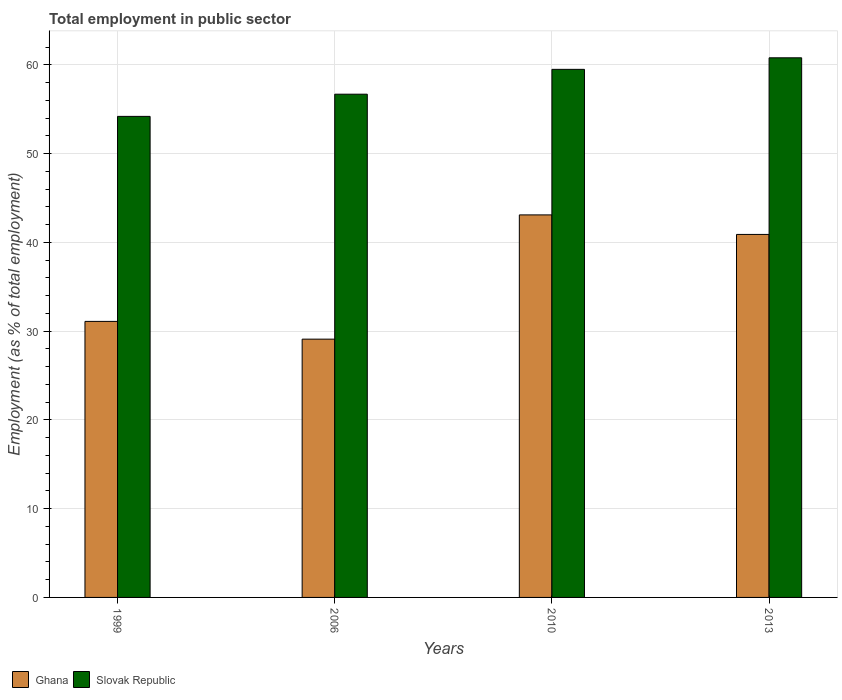How many different coloured bars are there?
Ensure brevity in your answer.  2. Are the number of bars per tick equal to the number of legend labels?
Your answer should be compact. Yes. How many bars are there on the 1st tick from the right?
Ensure brevity in your answer.  2. What is the label of the 4th group of bars from the left?
Keep it short and to the point. 2013. What is the employment in public sector in Ghana in 1999?
Make the answer very short. 31.1. Across all years, what is the maximum employment in public sector in Slovak Republic?
Provide a short and direct response. 60.8. Across all years, what is the minimum employment in public sector in Slovak Republic?
Your response must be concise. 54.2. What is the total employment in public sector in Slovak Republic in the graph?
Provide a short and direct response. 231.2. What is the difference between the employment in public sector in Ghana in 1999 and that in 2006?
Your answer should be very brief. 2. What is the difference between the employment in public sector in Slovak Republic in 2010 and the employment in public sector in Ghana in 2013?
Make the answer very short. 18.6. What is the average employment in public sector in Ghana per year?
Ensure brevity in your answer.  36.05. In the year 2013, what is the difference between the employment in public sector in Slovak Republic and employment in public sector in Ghana?
Your answer should be compact. 19.9. In how many years, is the employment in public sector in Slovak Republic greater than 22 %?
Your response must be concise. 4. What is the ratio of the employment in public sector in Ghana in 2006 to that in 2013?
Provide a succinct answer. 0.71. Is the employment in public sector in Ghana in 2006 less than that in 2010?
Your answer should be compact. Yes. What is the difference between the highest and the second highest employment in public sector in Ghana?
Provide a succinct answer. 2.2. What is the difference between the highest and the lowest employment in public sector in Slovak Republic?
Make the answer very short. 6.6. In how many years, is the employment in public sector in Ghana greater than the average employment in public sector in Ghana taken over all years?
Offer a terse response. 2. Is the sum of the employment in public sector in Slovak Republic in 2006 and 2010 greater than the maximum employment in public sector in Ghana across all years?
Make the answer very short. Yes. What does the 1st bar from the right in 2010 represents?
Your answer should be compact. Slovak Republic. How many bars are there?
Your response must be concise. 8. Are all the bars in the graph horizontal?
Your response must be concise. No. What is the difference between two consecutive major ticks on the Y-axis?
Make the answer very short. 10. Does the graph contain any zero values?
Ensure brevity in your answer.  No. Does the graph contain grids?
Your answer should be compact. Yes. Where does the legend appear in the graph?
Provide a succinct answer. Bottom left. How many legend labels are there?
Provide a succinct answer. 2. What is the title of the graph?
Provide a succinct answer. Total employment in public sector. What is the label or title of the Y-axis?
Offer a terse response. Employment (as % of total employment). What is the Employment (as % of total employment) of Ghana in 1999?
Your answer should be very brief. 31.1. What is the Employment (as % of total employment) of Slovak Republic in 1999?
Your response must be concise. 54.2. What is the Employment (as % of total employment) of Ghana in 2006?
Ensure brevity in your answer.  29.1. What is the Employment (as % of total employment) in Slovak Republic in 2006?
Give a very brief answer. 56.7. What is the Employment (as % of total employment) in Ghana in 2010?
Your response must be concise. 43.1. What is the Employment (as % of total employment) of Slovak Republic in 2010?
Your response must be concise. 59.5. What is the Employment (as % of total employment) of Ghana in 2013?
Give a very brief answer. 40.9. What is the Employment (as % of total employment) in Slovak Republic in 2013?
Ensure brevity in your answer.  60.8. Across all years, what is the maximum Employment (as % of total employment) in Ghana?
Your answer should be compact. 43.1. Across all years, what is the maximum Employment (as % of total employment) in Slovak Republic?
Give a very brief answer. 60.8. Across all years, what is the minimum Employment (as % of total employment) in Ghana?
Keep it short and to the point. 29.1. Across all years, what is the minimum Employment (as % of total employment) in Slovak Republic?
Make the answer very short. 54.2. What is the total Employment (as % of total employment) of Ghana in the graph?
Provide a succinct answer. 144.2. What is the total Employment (as % of total employment) of Slovak Republic in the graph?
Ensure brevity in your answer.  231.2. What is the difference between the Employment (as % of total employment) of Ghana in 1999 and that in 2006?
Provide a succinct answer. 2. What is the difference between the Employment (as % of total employment) in Slovak Republic in 1999 and that in 2006?
Give a very brief answer. -2.5. What is the difference between the Employment (as % of total employment) of Ghana in 1999 and that in 2010?
Your answer should be very brief. -12. What is the difference between the Employment (as % of total employment) in Slovak Republic in 1999 and that in 2010?
Your answer should be compact. -5.3. What is the difference between the Employment (as % of total employment) in Ghana in 1999 and that in 2013?
Give a very brief answer. -9.8. What is the difference between the Employment (as % of total employment) of Slovak Republic in 1999 and that in 2013?
Your answer should be very brief. -6.6. What is the difference between the Employment (as % of total employment) of Slovak Republic in 2006 and that in 2010?
Your response must be concise. -2.8. What is the difference between the Employment (as % of total employment) of Ghana in 2006 and that in 2013?
Make the answer very short. -11.8. What is the difference between the Employment (as % of total employment) in Ghana in 2010 and that in 2013?
Offer a terse response. 2.2. What is the difference between the Employment (as % of total employment) of Slovak Republic in 2010 and that in 2013?
Your answer should be very brief. -1.3. What is the difference between the Employment (as % of total employment) in Ghana in 1999 and the Employment (as % of total employment) in Slovak Republic in 2006?
Give a very brief answer. -25.6. What is the difference between the Employment (as % of total employment) in Ghana in 1999 and the Employment (as % of total employment) in Slovak Republic in 2010?
Give a very brief answer. -28.4. What is the difference between the Employment (as % of total employment) in Ghana in 1999 and the Employment (as % of total employment) in Slovak Republic in 2013?
Your answer should be very brief. -29.7. What is the difference between the Employment (as % of total employment) in Ghana in 2006 and the Employment (as % of total employment) in Slovak Republic in 2010?
Provide a succinct answer. -30.4. What is the difference between the Employment (as % of total employment) of Ghana in 2006 and the Employment (as % of total employment) of Slovak Republic in 2013?
Offer a very short reply. -31.7. What is the difference between the Employment (as % of total employment) of Ghana in 2010 and the Employment (as % of total employment) of Slovak Republic in 2013?
Your answer should be compact. -17.7. What is the average Employment (as % of total employment) in Ghana per year?
Provide a short and direct response. 36.05. What is the average Employment (as % of total employment) of Slovak Republic per year?
Provide a succinct answer. 57.8. In the year 1999, what is the difference between the Employment (as % of total employment) of Ghana and Employment (as % of total employment) of Slovak Republic?
Provide a short and direct response. -23.1. In the year 2006, what is the difference between the Employment (as % of total employment) of Ghana and Employment (as % of total employment) of Slovak Republic?
Make the answer very short. -27.6. In the year 2010, what is the difference between the Employment (as % of total employment) of Ghana and Employment (as % of total employment) of Slovak Republic?
Ensure brevity in your answer.  -16.4. In the year 2013, what is the difference between the Employment (as % of total employment) of Ghana and Employment (as % of total employment) of Slovak Republic?
Keep it short and to the point. -19.9. What is the ratio of the Employment (as % of total employment) of Ghana in 1999 to that in 2006?
Provide a short and direct response. 1.07. What is the ratio of the Employment (as % of total employment) in Slovak Republic in 1999 to that in 2006?
Make the answer very short. 0.96. What is the ratio of the Employment (as % of total employment) in Ghana in 1999 to that in 2010?
Your answer should be compact. 0.72. What is the ratio of the Employment (as % of total employment) in Slovak Republic in 1999 to that in 2010?
Keep it short and to the point. 0.91. What is the ratio of the Employment (as % of total employment) of Ghana in 1999 to that in 2013?
Your answer should be compact. 0.76. What is the ratio of the Employment (as % of total employment) of Slovak Republic in 1999 to that in 2013?
Offer a very short reply. 0.89. What is the ratio of the Employment (as % of total employment) in Ghana in 2006 to that in 2010?
Make the answer very short. 0.68. What is the ratio of the Employment (as % of total employment) in Slovak Republic in 2006 to that in 2010?
Offer a very short reply. 0.95. What is the ratio of the Employment (as % of total employment) in Ghana in 2006 to that in 2013?
Your response must be concise. 0.71. What is the ratio of the Employment (as % of total employment) in Slovak Republic in 2006 to that in 2013?
Offer a very short reply. 0.93. What is the ratio of the Employment (as % of total employment) of Ghana in 2010 to that in 2013?
Your response must be concise. 1.05. What is the ratio of the Employment (as % of total employment) of Slovak Republic in 2010 to that in 2013?
Offer a very short reply. 0.98. What is the difference between the highest and the lowest Employment (as % of total employment) in Ghana?
Your answer should be compact. 14. What is the difference between the highest and the lowest Employment (as % of total employment) of Slovak Republic?
Your response must be concise. 6.6. 